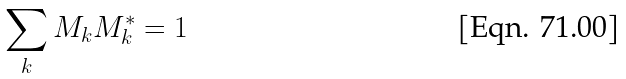Convert formula to latex. <formula><loc_0><loc_0><loc_500><loc_500>\sum _ { k } M _ { k } M _ { k } ^ { * } = 1</formula> 